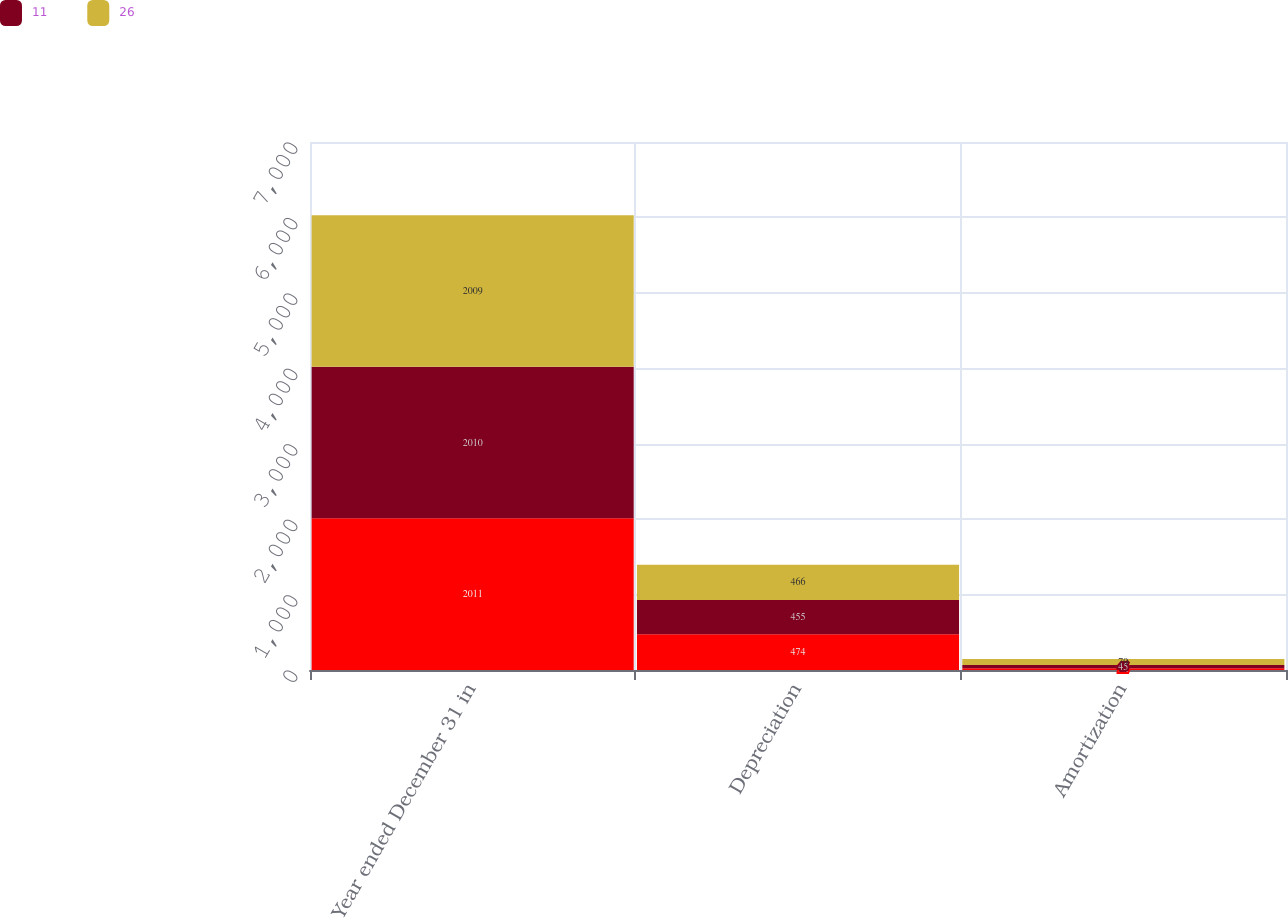<chart> <loc_0><loc_0><loc_500><loc_500><stacked_bar_chart><ecel><fcel>Year ended December 31 in<fcel>Depreciation<fcel>Amortization<nl><fcel>nan<fcel>2011<fcel>474<fcel>22<nl><fcel>11<fcel>2010<fcel>455<fcel>45<nl><fcel>26<fcel>2009<fcel>466<fcel>79<nl></chart> 